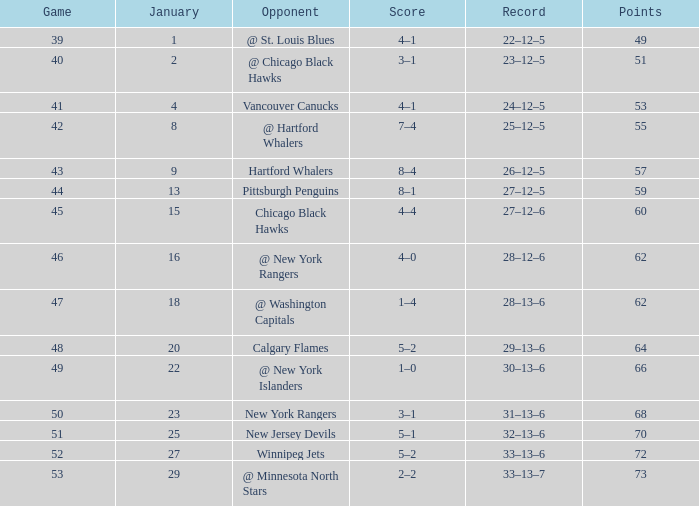Parse the full table. {'header': ['Game', 'January', 'Opponent', 'Score', 'Record', 'Points'], 'rows': [['39', '1', '@ St. Louis Blues', '4–1', '22–12–5', '49'], ['40', '2', '@ Chicago Black Hawks', '3–1', '23–12–5', '51'], ['41', '4', 'Vancouver Canucks', '4–1', '24–12–5', '53'], ['42', '8', '@ Hartford Whalers', '7–4', '25–12–5', '55'], ['43', '9', 'Hartford Whalers', '8–4', '26–12–5', '57'], ['44', '13', 'Pittsburgh Penguins', '8–1', '27–12–5', '59'], ['45', '15', 'Chicago Black Hawks', '4–4', '27–12–6', '60'], ['46', '16', '@ New York Rangers', '4–0', '28–12–6', '62'], ['47', '18', '@ Washington Capitals', '1–4', '28–13–6', '62'], ['48', '20', 'Calgary Flames', '5–2', '29–13–6', '64'], ['49', '22', '@ New York Islanders', '1–0', '30–13–6', '66'], ['50', '23', 'New York Rangers', '3–1', '31–13–6', '68'], ['51', '25', 'New Jersey Devils', '5–1', '32–13–6', '70'], ['52', '27', 'Winnipeg Jets', '5–2', '33–13–6', '72'], ['53', '29', '@ Minnesota North Stars', '2–2', '33–13–7', '73']]} In which january is there a score of 7–4, and a game less than 42? None. 